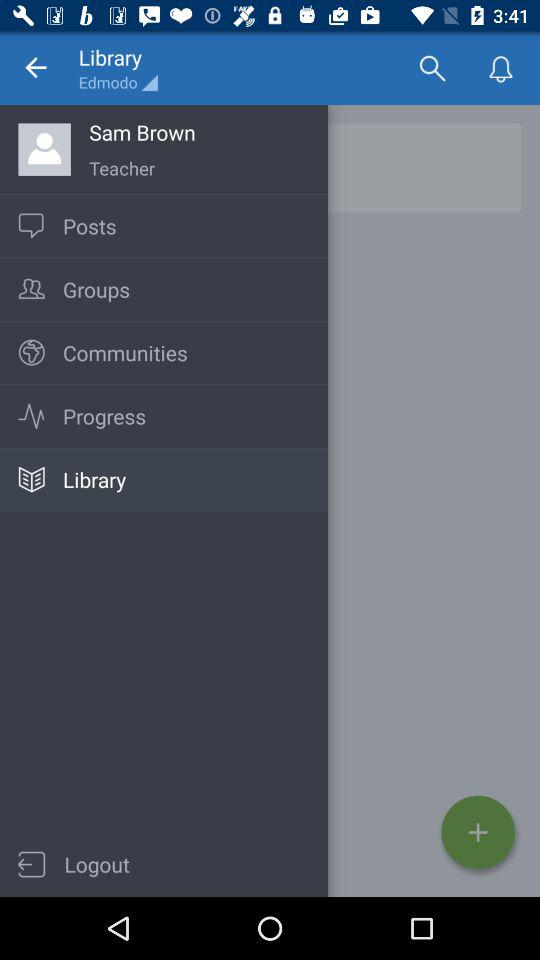What is the profession of Sam Brown? Sam Brown is a teacher. 